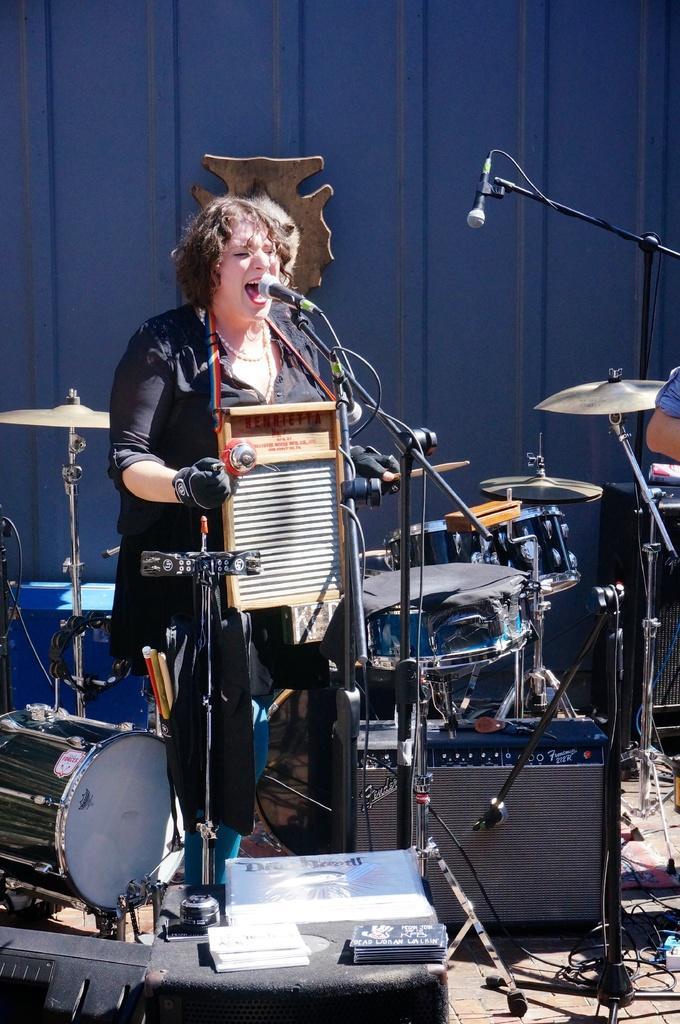Could you give a brief overview of what you see in this image? This woman is playing musical instrument and singing in-front of mic. Around this woman there are musical instruments and mic. 